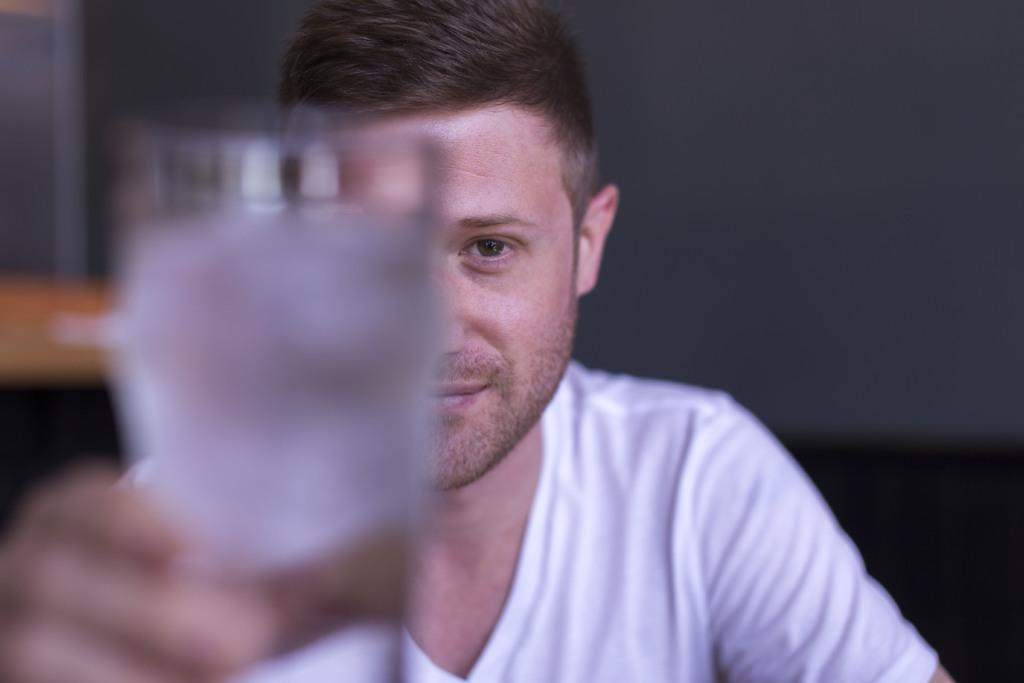Who or what is present in the image? There is a person in the image. What is the person holding in their hand? The person is holding a glass in their hand. What can be seen in the background of the image? There is a wall in the background of the image. Where might this image have been taken? The image may have been taken in a hall. How many stomachs does the person have in the image? The image does not show the person's stomach, so it cannot be determined how many stomachs they have. Is there a group of people in the image? No, there is only one person visible in the image. 